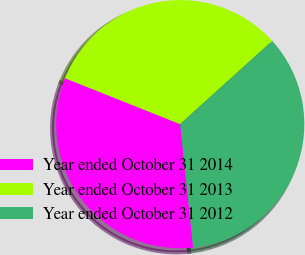<chart> <loc_0><loc_0><loc_500><loc_500><pie_chart><fcel>Year ended October 31 2014<fcel>Year ended October 31 2013<fcel>Year ended October 31 2012<nl><fcel>32.7%<fcel>32.27%<fcel>35.03%<nl></chart> 